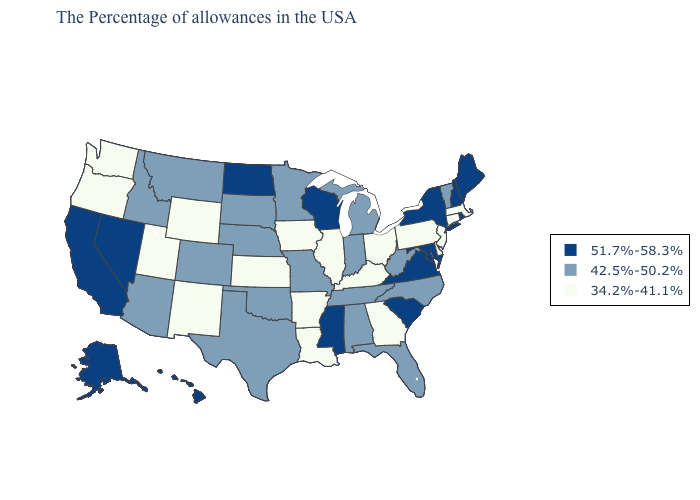Does Montana have the lowest value in the West?
Concise answer only. No. Which states hav the highest value in the West?
Be succinct. Nevada, California, Alaska, Hawaii. Does Arkansas have the highest value in the USA?
Write a very short answer. No. Is the legend a continuous bar?
Write a very short answer. No. Name the states that have a value in the range 42.5%-50.2%?
Quick response, please. Vermont, North Carolina, West Virginia, Florida, Michigan, Indiana, Alabama, Tennessee, Missouri, Minnesota, Nebraska, Oklahoma, Texas, South Dakota, Colorado, Montana, Arizona, Idaho. Does Iowa have the lowest value in the USA?
Keep it brief. Yes. Name the states that have a value in the range 51.7%-58.3%?
Short answer required. Maine, Rhode Island, New Hampshire, New York, Maryland, Virginia, South Carolina, Wisconsin, Mississippi, North Dakota, Nevada, California, Alaska, Hawaii. What is the lowest value in the USA?
Keep it brief. 34.2%-41.1%. What is the lowest value in the South?
Answer briefly. 34.2%-41.1%. Among the states that border Minnesota , does North Dakota have the highest value?
Write a very short answer. Yes. Is the legend a continuous bar?
Concise answer only. No. Name the states that have a value in the range 42.5%-50.2%?
Give a very brief answer. Vermont, North Carolina, West Virginia, Florida, Michigan, Indiana, Alabama, Tennessee, Missouri, Minnesota, Nebraska, Oklahoma, Texas, South Dakota, Colorado, Montana, Arizona, Idaho. Does Indiana have the same value as Nebraska?
Give a very brief answer. Yes. Among the states that border Rhode Island , which have the lowest value?
Short answer required. Massachusetts, Connecticut. Among the states that border Iowa , does Nebraska have the highest value?
Write a very short answer. No. 